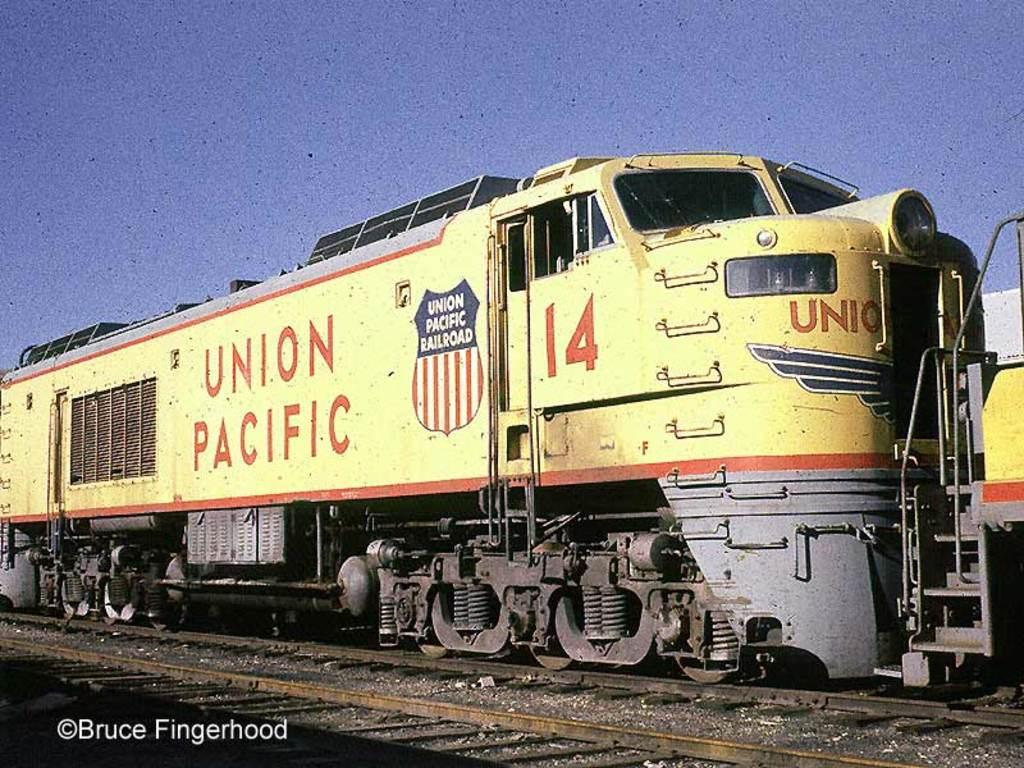What is the main subject of the image? The main subject of the image is a train. Where is the train located in the image? The train is on a railway track. What can be seen in the background of the image? There is sky visible in the background of the image. Is there any text present in the image? Yes, there is some text at the bottom of the image. How many units of mass can be seen in the image? There is no reference to units of mass in the image; it features a train on a railway track with sky in the background and some text at the bottom. 